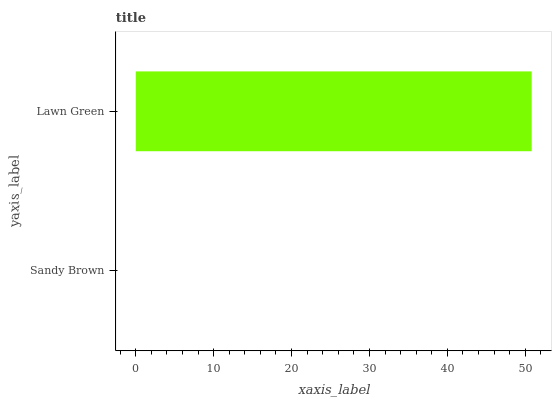Is Sandy Brown the minimum?
Answer yes or no. Yes. Is Lawn Green the maximum?
Answer yes or no. Yes. Is Lawn Green the minimum?
Answer yes or no. No. Is Lawn Green greater than Sandy Brown?
Answer yes or no. Yes. Is Sandy Brown less than Lawn Green?
Answer yes or no. Yes. Is Sandy Brown greater than Lawn Green?
Answer yes or no. No. Is Lawn Green less than Sandy Brown?
Answer yes or no. No. Is Lawn Green the high median?
Answer yes or no. Yes. Is Sandy Brown the low median?
Answer yes or no. Yes. Is Sandy Brown the high median?
Answer yes or no. No. Is Lawn Green the low median?
Answer yes or no. No. 